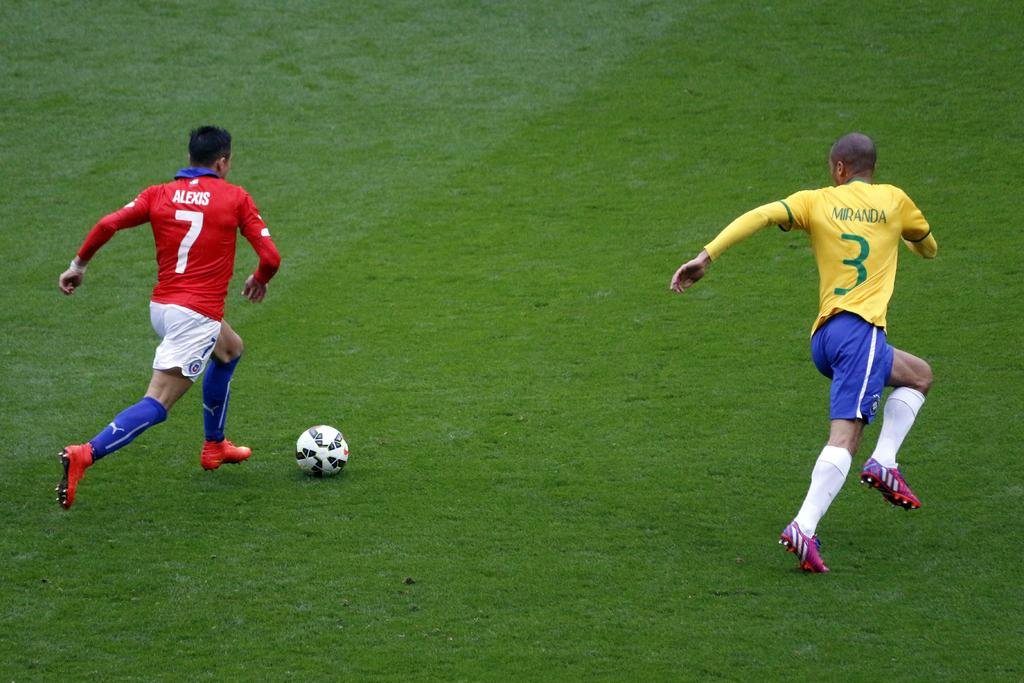<image>
Render a clear and concise summary of the photo. Player number 7 in red tries to get past player number 3 in yellow in a soccer game. 